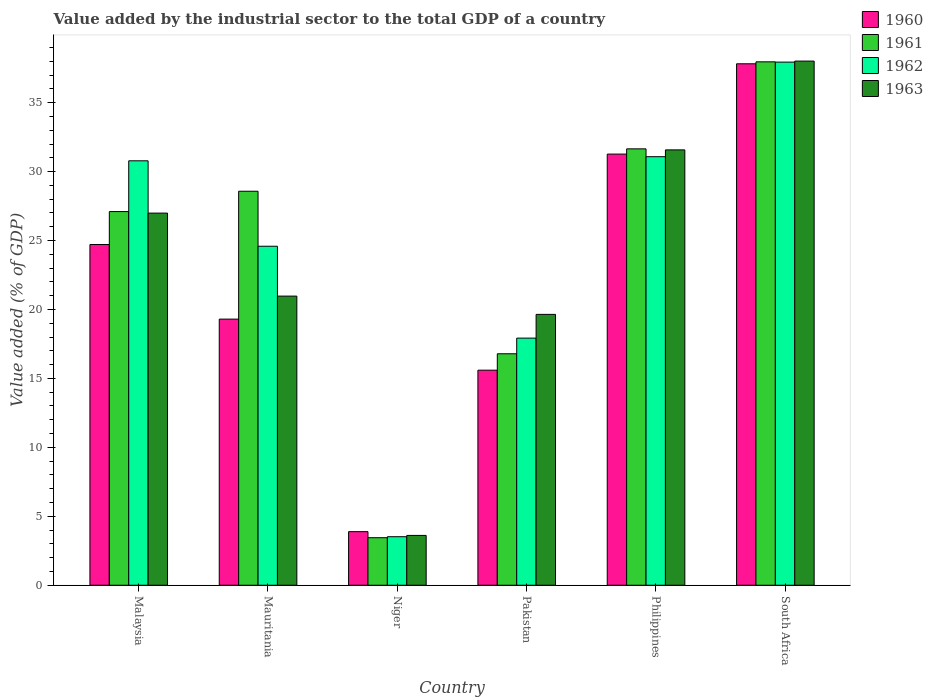Are the number of bars per tick equal to the number of legend labels?
Provide a succinct answer. Yes. How many bars are there on the 3rd tick from the left?
Give a very brief answer. 4. How many bars are there on the 6th tick from the right?
Your response must be concise. 4. What is the label of the 1st group of bars from the left?
Provide a short and direct response. Malaysia. What is the value added by the industrial sector to the total GDP in 1960 in Mauritania?
Offer a very short reply. 19.3. Across all countries, what is the maximum value added by the industrial sector to the total GDP in 1961?
Your response must be concise. 37.96. Across all countries, what is the minimum value added by the industrial sector to the total GDP in 1961?
Give a very brief answer. 3.45. In which country was the value added by the industrial sector to the total GDP in 1961 maximum?
Ensure brevity in your answer.  South Africa. In which country was the value added by the industrial sector to the total GDP in 1961 minimum?
Your answer should be very brief. Niger. What is the total value added by the industrial sector to the total GDP in 1963 in the graph?
Offer a terse response. 140.8. What is the difference between the value added by the industrial sector to the total GDP in 1963 in Mauritania and that in South Africa?
Provide a succinct answer. -17.04. What is the difference between the value added by the industrial sector to the total GDP in 1963 in Niger and the value added by the industrial sector to the total GDP in 1962 in Philippines?
Your answer should be compact. -27.47. What is the average value added by the industrial sector to the total GDP in 1962 per country?
Ensure brevity in your answer.  24.3. What is the difference between the value added by the industrial sector to the total GDP of/in 1961 and value added by the industrial sector to the total GDP of/in 1962 in Malaysia?
Give a very brief answer. -3.68. What is the ratio of the value added by the industrial sector to the total GDP in 1963 in Malaysia to that in Pakistan?
Provide a succinct answer. 1.37. What is the difference between the highest and the second highest value added by the industrial sector to the total GDP in 1962?
Offer a terse response. 7.16. What is the difference between the highest and the lowest value added by the industrial sector to the total GDP in 1961?
Offer a terse response. 34.51. In how many countries, is the value added by the industrial sector to the total GDP in 1960 greater than the average value added by the industrial sector to the total GDP in 1960 taken over all countries?
Offer a very short reply. 3. What does the 3rd bar from the right in Mauritania represents?
Give a very brief answer. 1961. Are all the bars in the graph horizontal?
Your response must be concise. No. Are the values on the major ticks of Y-axis written in scientific E-notation?
Keep it short and to the point. No. What is the title of the graph?
Your response must be concise. Value added by the industrial sector to the total GDP of a country. What is the label or title of the Y-axis?
Provide a succinct answer. Value added (% of GDP). What is the Value added (% of GDP) in 1960 in Malaysia?
Ensure brevity in your answer.  24.71. What is the Value added (% of GDP) of 1961 in Malaysia?
Ensure brevity in your answer.  27.1. What is the Value added (% of GDP) in 1962 in Malaysia?
Provide a short and direct response. 30.78. What is the Value added (% of GDP) of 1963 in Malaysia?
Give a very brief answer. 26.99. What is the Value added (% of GDP) in 1960 in Mauritania?
Provide a short and direct response. 19.3. What is the Value added (% of GDP) of 1961 in Mauritania?
Keep it short and to the point. 28.57. What is the Value added (% of GDP) of 1962 in Mauritania?
Your answer should be very brief. 24.59. What is the Value added (% of GDP) of 1963 in Mauritania?
Provide a short and direct response. 20.97. What is the Value added (% of GDP) in 1960 in Niger?
Your answer should be compact. 3.89. What is the Value added (% of GDP) of 1961 in Niger?
Provide a short and direct response. 3.45. What is the Value added (% of GDP) of 1962 in Niger?
Give a very brief answer. 3.52. What is the Value added (% of GDP) of 1963 in Niger?
Offer a very short reply. 3.61. What is the Value added (% of GDP) in 1960 in Pakistan?
Make the answer very short. 15.6. What is the Value added (% of GDP) in 1961 in Pakistan?
Give a very brief answer. 16.79. What is the Value added (% of GDP) in 1962 in Pakistan?
Provide a succinct answer. 17.92. What is the Value added (% of GDP) of 1963 in Pakistan?
Keep it short and to the point. 19.64. What is the Value added (% of GDP) of 1960 in Philippines?
Your answer should be compact. 31.27. What is the Value added (% of GDP) in 1961 in Philippines?
Your answer should be very brief. 31.65. What is the Value added (% of GDP) in 1962 in Philippines?
Give a very brief answer. 31.08. What is the Value added (% of GDP) of 1963 in Philippines?
Your answer should be compact. 31.57. What is the Value added (% of GDP) of 1960 in South Africa?
Provide a succinct answer. 37.82. What is the Value added (% of GDP) of 1961 in South Africa?
Keep it short and to the point. 37.96. What is the Value added (% of GDP) of 1962 in South Africa?
Provide a short and direct response. 37.94. What is the Value added (% of GDP) of 1963 in South Africa?
Give a very brief answer. 38.01. Across all countries, what is the maximum Value added (% of GDP) of 1960?
Offer a very short reply. 37.82. Across all countries, what is the maximum Value added (% of GDP) in 1961?
Your response must be concise. 37.96. Across all countries, what is the maximum Value added (% of GDP) of 1962?
Provide a short and direct response. 37.94. Across all countries, what is the maximum Value added (% of GDP) of 1963?
Your response must be concise. 38.01. Across all countries, what is the minimum Value added (% of GDP) of 1960?
Ensure brevity in your answer.  3.89. Across all countries, what is the minimum Value added (% of GDP) of 1961?
Give a very brief answer. 3.45. Across all countries, what is the minimum Value added (% of GDP) in 1962?
Provide a short and direct response. 3.52. Across all countries, what is the minimum Value added (% of GDP) in 1963?
Ensure brevity in your answer.  3.61. What is the total Value added (% of GDP) of 1960 in the graph?
Keep it short and to the point. 132.58. What is the total Value added (% of GDP) of 1961 in the graph?
Provide a short and direct response. 145.51. What is the total Value added (% of GDP) in 1962 in the graph?
Your response must be concise. 145.83. What is the total Value added (% of GDP) in 1963 in the graph?
Ensure brevity in your answer.  140.8. What is the difference between the Value added (% of GDP) of 1960 in Malaysia and that in Mauritania?
Give a very brief answer. 5.41. What is the difference between the Value added (% of GDP) of 1961 in Malaysia and that in Mauritania?
Keep it short and to the point. -1.47. What is the difference between the Value added (% of GDP) in 1962 in Malaysia and that in Mauritania?
Give a very brief answer. 6.2. What is the difference between the Value added (% of GDP) of 1963 in Malaysia and that in Mauritania?
Offer a terse response. 6.02. What is the difference between the Value added (% of GDP) in 1960 in Malaysia and that in Niger?
Provide a short and direct response. 20.83. What is the difference between the Value added (% of GDP) of 1961 in Malaysia and that in Niger?
Ensure brevity in your answer.  23.65. What is the difference between the Value added (% of GDP) in 1962 in Malaysia and that in Niger?
Offer a terse response. 27.26. What is the difference between the Value added (% of GDP) in 1963 in Malaysia and that in Niger?
Keep it short and to the point. 23.38. What is the difference between the Value added (% of GDP) in 1960 in Malaysia and that in Pakistan?
Provide a succinct answer. 9.11. What is the difference between the Value added (% of GDP) in 1961 in Malaysia and that in Pakistan?
Your answer should be very brief. 10.31. What is the difference between the Value added (% of GDP) of 1962 in Malaysia and that in Pakistan?
Offer a very short reply. 12.86. What is the difference between the Value added (% of GDP) in 1963 in Malaysia and that in Pakistan?
Offer a terse response. 7.35. What is the difference between the Value added (% of GDP) of 1960 in Malaysia and that in Philippines?
Provide a succinct answer. -6.56. What is the difference between the Value added (% of GDP) of 1961 in Malaysia and that in Philippines?
Make the answer very short. -4.55. What is the difference between the Value added (% of GDP) of 1962 in Malaysia and that in Philippines?
Keep it short and to the point. -0.3. What is the difference between the Value added (% of GDP) of 1963 in Malaysia and that in Philippines?
Your answer should be very brief. -4.58. What is the difference between the Value added (% of GDP) of 1960 in Malaysia and that in South Africa?
Ensure brevity in your answer.  -13.11. What is the difference between the Value added (% of GDP) of 1961 in Malaysia and that in South Africa?
Make the answer very short. -10.86. What is the difference between the Value added (% of GDP) in 1962 in Malaysia and that in South Africa?
Offer a terse response. -7.16. What is the difference between the Value added (% of GDP) of 1963 in Malaysia and that in South Africa?
Offer a very short reply. -11.02. What is the difference between the Value added (% of GDP) of 1960 in Mauritania and that in Niger?
Offer a terse response. 15.41. What is the difference between the Value added (% of GDP) of 1961 in Mauritania and that in Niger?
Your answer should be compact. 25.13. What is the difference between the Value added (% of GDP) in 1962 in Mauritania and that in Niger?
Provide a short and direct response. 21.07. What is the difference between the Value added (% of GDP) of 1963 in Mauritania and that in Niger?
Ensure brevity in your answer.  17.36. What is the difference between the Value added (% of GDP) of 1960 in Mauritania and that in Pakistan?
Give a very brief answer. 3.7. What is the difference between the Value added (% of GDP) of 1961 in Mauritania and that in Pakistan?
Offer a very short reply. 11.79. What is the difference between the Value added (% of GDP) in 1962 in Mauritania and that in Pakistan?
Make the answer very short. 6.66. What is the difference between the Value added (% of GDP) of 1963 in Mauritania and that in Pakistan?
Ensure brevity in your answer.  1.33. What is the difference between the Value added (% of GDP) of 1960 in Mauritania and that in Philippines?
Your response must be concise. -11.97. What is the difference between the Value added (% of GDP) of 1961 in Mauritania and that in Philippines?
Offer a very short reply. -3.07. What is the difference between the Value added (% of GDP) of 1962 in Mauritania and that in Philippines?
Keep it short and to the point. -6.49. What is the difference between the Value added (% of GDP) in 1963 in Mauritania and that in Philippines?
Provide a succinct answer. -10.6. What is the difference between the Value added (% of GDP) of 1960 in Mauritania and that in South Africa?
Provide a succinct answer. -18.52. What is the difference between the Value added (% of GDP) in 1961 in Mauritania and that in South Africa?
Your answer should be compact. -9.38. What is the difference between the Value added (% of GDP) of 1962 in Mauritania and that in South Africa?
Your answer should be compact. -13.35. What is the difference between the Value added (% of GDP) of 1963 in Mauritania and that in South Africa?
Provide a short and direct response. -17.04. What is the difference between the Value added (% of GDP) in 1960 in Niger and that in Pakistan?
Your answer should be very brief. -11.71. What is the difference between the Value added (% of GDP) in 1961 in Niger and that in Pakistan?
Offer a terse response. -13.34. What is the difference between the Value added (% of GDP) in 1962 in Niger and that in Pakistan?
Ensure brevity in your answer.  -14.4. What is the difference between the Value added (% of GDP) of 1963 in Niger and that in Pakistan?
Offer a terse response. -16.03. What is the difference between the Value added (% of GDP) in 1960 in Niger and that in Philippines?
Your answer should be compact. -27.38. What is the difference between the Value added (% of GDP) of 1961 in Niger and that in Philippines?
Make the answer very short. -28.2. What is the difference between the Value added (% of GDP) of 1962 in Niger and that in Philippines?
Offer a very short reply. -27.56. What is the difference between the Value added (% of GDP) of 1963 in Niger and that in Philippines?
Ensure brevity in your answer.  -27.96. What is the difference between the Value added (% of GDP) of 1960 in Niger and that in South Africa?
Make the answer very short. -33.93. What is the difference between the Value added (% of GDP) of 1961 in Niger and that in South Africa?
Ensure brevity in your answer.  -34.51. What is the difference between the Value added (% of GDP) in 1962 in Niger and that in South Africa?
Make the answer very short. -34.42. What is the difference between the Value added (% of GDP) in 1963 in Niger and that in South Africa?
Keep it short and to the point. -34.4. What is the difference between the Value added (% of GDP) of 1960 in Pakistan and that in Philippines?
Provide a short and direct response. -15.67. What is the difference between the Value added (% of GDP) in 1961 in Pakistan and that in Philippines?
Provide a short and direct response. -14.86. What is the difference between the Value added (% of GDP) in 1962 in Pakistan and that in Philippines?
Your answer should be compact. -13.16. What is the difference between the Value added (% of GDP) in 1963 in Pakistan and that in Philippines?
Your response must be concise. -11.93. What is the difference between the Value added (% of GDP) in 1960 in Pakistan and that in South Africa?
Your answer should be compact. -22.22. What is the difference between the Value added (% of GDP) in 1961 in Pakistan and that in South Africa?
Provide a short and direct response. -21.17. What is the difference between the Value added (% of GDP) in 1962 in Pakistan and that in South Africa?
Provide a short and direct response. -20.02. What is the difference between the Value added (% of GDP) of 1963 in Pakistan and that in South Africa?
Offer a very short reply. -18.37. What is the difference between the Value added (% of GDP) of 1960 in Philippines and that in South Africa?
Your response must be concise. -6.55. What is the difference between the Value added (% of GDP) in 1961 in Philippines and that in South Africa?
Keep it short and to the point. -6.31. What is the difference between the Value added (% of GDP) in 1962 in Philippines and that in South Africa?
Offer a very short reply. -6.86. What is the difference between the Value added (% of GDP) of 1963 in Philippines and that in South Africa?
Your answer should be compact. -6.44. What is the difference between the Value added (% of GDP) of 1960 in Malaysia and the Value added (% of GDP) of 1961 in Mauritania?
Make the answer very short. -3.86. What is the difference between the Value added (% of GDP) of 1960 in Malaysia and the Value added (% of GDP) of 1962 in Mauritania?
Offer a terse response. 0.13. What is the difference between the Value added (% of GDP) of 1960 in Malaysia and the Value added (% of GDP) of 1963 in Mauritania?
Provide a succinct answer. 3.74. What is the difference between the Value added (% of GDP) of 1961 in Malaysia and the Value added (% of GDP) of 1962 in Mauritania?
Provide a short and direct response. 2.51. What is the difference between the Value added (% of GDP) in 1961 in Malaysia and the Value added (% of GDP) in 1963 in Mauritania?
Make the answer very short. 6.13. What is the difference between the Value added (% of GDP) in 1962 in Malaysia and the Value added (% of GDP) in 1963 in Mauritania?
Keep it short and to the point. 9.81. What is the difference between the Value added (% of GDP) in 1960 in Malaysia and the Value added (% of GDP) in 1961 in Niger?
Provide a succinct answer. 21.27. What is the difference between the Value added (% of GDP) in 1960 in Malaysia and the Value added (% of GDP) in 1962 in Niger?
Make the answer very short. 21.19. What is the difference between the Value added (% of GDP) of 1960 in Malaysia and the Value added (% of GDP) of 1963 in Niger?
Offer a very short reply. 21.1. What is the difference between the Value added (% of GDP) of 1961 in Malaysia and the Value added (% of GDP) of 1962 in Niger?
Offer a terse response. 23.58. What is the difference between the Value added (% of GDP) of 1961 in Malaysia and the Value added (% of GDP) of 1963 in Niger?
Your answer should be very brief. 23.49. What is the difference between the Value added (% of GDP) of 1962 in Malaysia and the Value added (% of GDP) of 1963 in Niger?
Offer a terse response. 27.17. What is the difference between the Value added (% of GDP) of 1960 in Malaysia and the Value added (% of GDP) of 1961 in Pakistan?
Your answer should be compact. 7.92. What is the difference between the Value added (% of GDP) of 1960 in Malaysia and the Value added (% of GDP) of 1962 in Pakistan?
Your answer should be very brief. 6.79. What is the difference between the Value added (% of GDP) in 1960 in Malaysia and the Value added (% of GDP) in 1963 in Pakistan?
Provide a succinct answer. 5.07. What is the difference between the Value added (% of GDP) of 1961 in Malaysia and the Value added (% of GDP) of 1962 in Pakistan?
Make the answer very short. 9.18. What is the difference between the Value added (% of GDP) of 1961 in Malaysia and the Value added (% of GDP) of 1963 in Pakistan?
Offer a terse response. 7.46. What is the difference between the Value added (% of GDP) of 1962 in Malaysia and the Value added (% of GDP) of 1963 in Pakistan?
Your answer should be very brief. 11.14. What is the difference between the Value added (% of GDP) of 1960 in Malaysia and the Value added (% of GDP) of 1961 in Philippines?
Offer a terse response. -6.94. What is the difference between the Value added (% of GDP) in 1960 in Malaysia and the Value added (% of GDP) in 1962 in Philippines?
Provide a short and direct response. -6.37. What is the difference between the Value added (% of GDP) in 1960 in Malaysia and the Value added (% of GDP) in 1963 in Philippines?
Provide a succinct answer. -6.86. What is the difference between the Value added (% of GDP) in 1961 in Malaysia and the Value added (% of GDP) in 1962 in Philippines?
Keep it short and to the point. -3.98. What is the difference between the Value added (% of GDP) in 1961 in Malaysia and the Value added (% of GDP) in 1963 in Philippines?
Your answer should be compact. -4.47. What is the difference between the Value added (% of GDP) in 1962 in Malaysia and the Value added (% of GDP) in 1963 in Philippines?
Give a very brief answer. -0.79. What is the difference between the Value added (% of GDP) in 1960 in Malaysia and the Value added (% of GDP) in 1961 in South Africa?
Make the answer very short. -13.25. What is the difference between the Value added (% of GDP) of 1960 in Malaysia and the Value added (% of GDP) of 1962 in South Africa?
Offer a very short reply. -13.23. What is the difference between the Value added (% of GDP) in 1960 in Malaysia and the Value added (% of GDP) in 1963 in South Africa?
Provide a short and direct response. -13.3. What is the difference between the Value added (% of GDP) of 1961 in Malaysia and the Value added (% of GDP) of 1962 in South Africa?
Your response must be concise. -10.84. What is the difference between the Value added (% of GDP) of 1961 in Malaysia and the Value added (% of GDP) of 1963 in South Africa?
Keep it short and to the point. -10.91. What is the difference between the Value added (% of GDP) in 1962 in Malaysia and the Value added (% of GDP) in 1963 in South Africa?
Make the answer very short. -7.23. What is the difference between the Value added (% of GDP) of 1960 in Mauritania and the Value added (% of GDP) of 1961 in Niger?
Make the answer very short. 15.85. What is the difference between the Value added (% of GDP) of 1960 in Mauritania and the Value added (% of GDP) of 1962 in Niger?
Provide a succinct answer. 15.78. What is the difference between the Value added (% of GDP) of 1960 in Mauritania and the Value added (% of GDP) of 1963 in Niger?
Your response must be concise. 15.69. What is the difference between the Value added (% of GDP) of 1961 in Mauritania and the Value added (% of GDP) of 1962 in Niger?
Offer a terse response. 25.05. What is the difference between the Value added (% of GDP) in 1961 in Mauritania and the Value added (% of GDP) in 1963 in Niger?
Your response must be concise. 24.96. What is the difference between the Value added (% of GDP) of 1962 in Mauritania and the Value added (% of GDP) of 1963 in Niger?
Keep it short and to the point. 20.97. What is the difference between the Value added (% of GDP) in 1960 in Mauritania and the Value added (% of GDP) in 1961 in Pakistan?
Provide a succinct answer. 2.51. What is the difference between the Value added (% of GDP) in 1960 in Mauritania and the Value added (% of GDP) in 1962 in Pakistan?
Your answer should be compact. 1.38. What is the difference between the Value added (% of GDP) of 1960 in Mauritania and the Value added (% of GDP) of 1963 in Pakistan?
Keep it short and to the point. -0.34. What is the difference between the Value added (% of GDP) of 1961 in Mauritania and the Value added (% of GDP) of 1962 in Pakistan?
Keep it short and to the point. 10.65. What is the difference between the Value added (% of GDP) in 1961 in Mauritania and the Value added (% of GDP) in 1963 in Pakistan?
Offer a very short reply. 8.93. What is the difference between the Value added (% of GDP) of 1962 in Mauritania and the Value added (% of GDP) of 1963 in Pakistan?
Ensure brevity in your answer.  4.94. What is the difference between the Value added (% of GDP) of 1960 in Mauritania and the Value added (% of GDP) of 1961 in Philippines?
Your answer should be very brief. -12.35. What is the difference between the Value added (% of GDP) in 1960 in Mauritania and the Value added (% of GDP) in 1962 in Philippines?
Offer a very short reply. -11.78. What is the difference between the Value added (% of GDP) of 1960 in Mauritania and the Value added (% of GDP) of 1963 in Philippines?
Provide a short and direct response. -12.27. What is the difference between the Value added (% of GDP) of 1961 in Mauritania and the Value added (% of GDP) of 1962 in Philippines?
Keep it short and to the point. -2.51. What is the difference between the Value added (% of GDP) in 1961 in Mauritania and the Value added (% of GDP) in 1963 in Philippines?
Make the answer very short. -3. What is the difference between the Value added (% of GDP) in 1962 in Mauritania and the Value added (% of GDP) in 1963 in Philippines?
Provide a short and direct response. -6.99. What is the difference between the Value added (% of GDP) of 1960 in Mauritania and the Value added (% of GDP) of 1961 in South Africa?
Provide a short and direct response. -18.66. What is the difference between the Value added (% of GDP) in 1960 in Mauritania and the Value added (% of GDP) in 1962 in South Africa?
Offer a very short reply. -18.64. What is the difference between the Value added (% of GDP) in 1960 in Mauritania and the Value added (% of GDP) in 1963 in South Africa?
Your answer should be very brief. -18.71. What is the difference between the Value added (% of GDP) in 1961 in Mauritania and the Value added (% of GDP) in 1962 in South Africa?
Your response must be concise. -9.36. What is the difference between the Value added (% of GDP) in 1961 in Mauritania and the Value added (% of GDP) in 1963 in South Africa?
Your answer should be very brief. -9.44. What is the difference between the Value added (% of GDP) in 1962 in Mauritania and the Value added (% of GDP) in 1963 in South Africa?
Provide a short and direct response. -13.43. What is the difference between the Value added (% of GDP) of 1960 in Niger and the Value added (% of GDP) of 1961 in Pakistan?
Offer a very short reply. -12.9. What is the difference between the Value added (% of GDP) in 1960 in Niger and the Value added (% of GDP) in 1962 in Pakistan?
Offer a terse response. -14.04. What is the difference between the Value added (% of GDP) in 1960 in Niger and the Value added (% of GDP) in 1963 in Pakistan?
Your answer should be compact. -15.76. What is the difference between the Value added (% of GDP) in 1961 in Niger and the Value added (% of GDP) in 1962 in Pakistan?
Ensure brevity in your answer.  -14.48. What is the difference between the Value added (% of GDP) in 1961 in Niger and the Value added (% of GDP) in 1963 in Pakistan?
Keep it short and to the point. -16.2. What is the difference between the Value added (% of GDP) in 1962 in Niger and the Value added (% of GDP) in 1963 in Pakistan?
Ensure brevity in your answer.  -16.12. What is the difference between the Value added (% of GDP) in 1960 in Niger and the Value added (% of GDP) in 1961 in Philippines?
Provide a succinct answer. -27.76. What is the difference between the Value added (% of GDP) in 1960 in Niger and the Value added (% of GDP) in 1962 in Philippines?
Provide a succinct answer. -27.19. What is the difference between the Value added (% of GDP) of 1960 in Niger and the Value added (% of GDP) of 1963 in Philippines?
Your answer should be very brief. -27.69. What is the difference between the Value added (% of GDP) of 1961 in Niger and the Value added (% of GDP) of 1962 in Philippines?
Offer a very short reply. -27.63. What is the difference between the Value added (% of GDP) in 1961 in Niger and the Value added (% of GDP) in 1963 in Philippines?
Give a very brief answer. -28.13. What is the difference between the Value added (% of GDP) of 1962 in Niger and the Value added (% of GDP) of 1963 in Philippines?
Your answer should be very brief. -28.05. What is the difference between the Value added (% of GDP) in 1960 in Niger and the Value added (% of GDP) in 1961 in South Africa?
Make the answer very short. -34.07. What is the difference between the Value added (% of GDP) in 1960 in Niger and the Value added (% of GDP) in 1962 in South Africa?
Your answer should be very brief. -34.05. What is the difference between the Value added (% of GDP) in 1960 in Niger and the Value added (% of GDP) in 1963 in South Africa?
Give a very brief answer. -34.13. What is the difference between the Value added (% of GDP) in 1961 in Niger and the Value added (% of GDP) in 1962 in South Africa?
Provide a succinct answer. -34.49. What is the difference between the Value added (% of GDP) of 1961 in Niger and the Value added (% of GDP) of 1963 in South Africa?
Make the answer very short. -34.57. What is the difference between the Value added (% of GDP) of 1962 in Niger and the Value added (% of GDP) of 1963 in South Africa?
Ensure brevity in your answer.  -34.49. What is the difference between the Value added (% of GDP) of 1960 in Pakistan and the Value added (% of GDP) of 1961 in Philippines?
Offer a very short reply. -16.05. What is the difference between the Value added (% of GDP) of 1960 in Pakistan and the Value added (% of GDP) of 1962 in Philippines?
Your answer should be compact. -15.48. What is the difference between the Value added (% of GDP) of 1960 in Pakistan and the Value added (% of GDP) of 1963 in Philippines?
Provide a succinct answer. -15.98. What is the difference between the Value added (% of GDP) of 1961 in Pakistan and the Value added (% of GDP) of 1962 in Philippines?
Offer a very short reply. -14.29. What is the difference between the Value added (% of GDP) in 1961 in Pakistan and the Value added (% of GDP) in 1963 in Philippines?
Make the answer very short. -14.79. What is the difference between the Value added (% of GDP) in 1962 in Pakistan and the Value added (% of GDP) in 1963 in Philippines?
Your response must be concise. -13.65. What is the difference between the Value added (% of GDP) of 1960 in Pakistan and the Value added (% of GDP) of 1961 in South Africa?
Keep it short and to the point. -22.36. What is the difference between the Value added (% of GDP) in 1960 in Pakistan and the Value added (% of GDP) in 1962 in South Africa?
Offer a terse response. -22.34. What is the difference between the Value added (% of GDP) in 1960 in Pakistan and the Value added (% of GDP) in 1963 in South Africa?
Provide a short and direct response. -22.42. What is the difference between the Value added (% of GDP) of 1961 in Pakistan and the Value added (% of GDP) of 1962 in South Africa?
Your answer should be compact. -21.15. What is the difference between the Value added (% of GDP) of 1961 in Pakistan and the Value added (% of GDP) of 1963 in South Africa?
Your response must be concise. -21.23. What is the difference between the Value added (% of GDP) in 1962 in Pakistan and the Value added (% of GDP) in 1963 in South Africa?
Your answer should be very brief. -20.09. What is the difference between the Value added (% of GDP) in 1960 in Philippines and the Value added (% of GDP) in 1961 in South Africa?
Make the answer very short. -6.69. What is the difference between the Value added (% of GDP) in 1960 in Philippines and the Value added (% of GDP) in 1962 in South Africa?
Keep it short and to the point. -6.67. What is the difference between the Value added (% of GDP) in 1960 in Philippines and the Value added (% of GDP) in 1963 in South Africa?
Keep it short and to the point. -6.75. What is the difference between the Value added (% of GDP) in 1961 in Philippines and the Value added (% of GDP) in 1962 in South Africa?
Provide a succinct answer. -6.29. What is the difference between the Value added (% of GDP) in 1961 in Philippines and the Value added (% of GDP) in 1963 in South Africa?
Your answer should be very brief. -6.37. What is the difference between the Value added (% of GDP) in 1962 in Philippines and the Value added (% of GDP) in 1963 in South Africa?
Offer a terse response. -6.93. What is the average Value added (% of GDP) in 1960 per country?
Keep it short and to the point. 22.1. What is the average Value added (% of GDP) in 1961 per country?
Give a very brief answer. 24.25. What is the average Value added (% of GDP) of 1962 per country?
Keep it short and to the point. 24.3. What is the average Value added (% of GDP) of 1963 per country?
Provide a succinct answer. 23.47. What is the difference between the Value added (% of GDP) in 1960 and Value added (% of GDP) in 1961 in Malaysia?
Your response must be concise. -2.39. What is the difference between the Value added (% of GDP) in 1960 and Value added (% of GDP) in 1962 in Malaysia?
Your answer should be very brief. -6.07. What is the difference between the Value added (% of GDP) in 1960 and Value added (% of GDP) in 1963 in Malaysia?
Your answer should be very brief. -2.28. What is the difference between the Value added (% of GDP) in 1961 and Value added (% of GDP) in 1962 in Malaysia?
Offer a terse response. -3.68. What is the difference between the Value added (% of GDP) of 1961 and Value added (% of GDP) of 1963 in Malaysia?
Offer a terse response. 0.11. What is the difference between the Value added (% of GDP) in 1962 and Value added (% of GDP) in 1963 in Malaysia?
Ensure brevity in your answer.  3.79. What is the difference between the Value added (% of GDP) in 1960 and Value added (% of GDP) in 1961 in Mauritania?
Your answer should be compact. -9.27. What is the difference between the Value added (% of GDP) of 1960 and Value added (% of GDP) of 1962 in Mauritania?
Give a very brief answer. -5.29. What is the difference between the Value added (% of GDP) in 1960 and Value added (% of GDP) in 1963 in Mauritania?
Your answer should be very brief. -1.67. What is the difference between the Value added (% of GDP) in 1961 and Value added (% of GDP) in 1962 in Mauritania?
Provide a short and direct response. 3.99. What is the difference between the Value added (% of GDP) in 1961 and Value added (% of GDP) in 1963 in Mauritania?
Offer a terse response. 7.6. What is the difference between the Value added (% of GDP) of 1962 and Value added (% of GDP) of 1963 in Mauritania?
Ensure brevity in your answer.  3.62. What is the difference between the Value added (% of GDP) in 1960 and Value added (% of GDP) in 1961 in Niger?
Ensure brevity in your answer.  0.44. What is the difference between the Value added (% of GDP) in 1960 and Value added (% of GDP) in 1962 in Niger?
Keep it short and to the point. 0.37. What is the difference between the Value added (% of GDP) in 1960 and Value added (% of GDP) in 1963 in Niger?
Your response must be concise. 0.27. What is the difference between the Value added (% of GDP) in 1961 and Value added (% of GDP) in 1962 in Niger?
Provide a succinct answer. -0.07. What is the difference between the Value added (% of GDP) in 1961 and Value added (% of GDP) in 1963 in Niger?
Make the answer very short. -0.17. What is the difference between the Value added (% of GDP) of 1962 and Value added (% of GDP) of 1963 in Niger?
Offer a very short reply. -0.09. What is the difference between the Value added (% of GDP) in 1960 and Value added (% of GDP) in 1961 in Pakistan?
Ensure brevity in your answer.  -1.19. What is the difference between the Value added (% of GDP) in 1960 and Value added (% of GDP) in 1962 in Pakistan?
Your answer should be very brief. -2.33. What is the difference between the Value added (% of GDP) of 1960 and Value added (% of GDP) of 1963 in Pakistan?
Ensure brevity in your answer.  -4.05. What is the difference between the Value added (% of GDP) in 1961 and Value added (% of GDP) in 1962 in Pakistan?
Provide a succinct answer. -1.14. What is the difference between the Value added (% of GDP) of 1961 and Value added (% of GDP) of 1963 in Pakistan?
Provide a short and direct response. -2.86. What is the difference between the Value added (% of GDP) of 1962 and Value added (% of GDP) of 1963 in Pakistan?
Ensure brevity in your answer.  -1.72. What is the difference between the Value added (% of GDP) in 1960 and Value added (% of GDP) in 1961 in Philippines?
Keep it short and to the point. -0.38. What is the difference between the Value added (% of GDP) in 1960 and Value added (% of GDP) in 1962 in Philippines?
Your answer should be very brief. 0.19. What is the difference between the Value added (% of GDP) of 1960 and Value added (% of GDP) of 1963 in Philippines?
Your response must be concise. -0.3. What is the difference between the Value added (% of GDP) of 1961 and Value added (% of GDP) of 1962 in Philippines?
Offer a very short reply. 0.57. What is the difference between the Value added (% of GDP) in 1961 and Value added (% of GDP) in 1963 in Philippines?
Keep it short and to the point. 0.08. What is the difference between the Value added (% of GDP) of 1962 and Value added (% of GDP) of 1963 in Philippines?
Keep it short and to the point. -0.49. What is the difference between the Value added (% of GDP) in 1960 and Value added (% of GDP) in 1961 in South Africa?
Ensure brevity in your answer.  -0.14. What is the difference between the Value added (% of GDP) in 1960 and Value added (% of GDP) in 1962 in South Africa?
Your answer should be very brief. -0.12. What is the difference between the Value added (% of GDP) in 1960 and Value added (% of GDP) in 1963 in South Africa?
Offer a terse response. -0.2. What is the difference between the Value added (% of GDP) in 1961 and Value added (% of GDP) in 1962 in South Africa?
Ensure brevity in your answer.  0.02. What is the difference between the Value added (% of GDP) in 1961 and Value added (% of GDP) in 1963 in South Africa?
Offer a terse response. -0.05. What is the difference between the Value added (% of GDP) of 1962 and Value added (% of GDP) of 1963 in South Africa?
Provide a succinct answer. -0.08. What is the ratio of the Value added (% of GDP) of 1960 in Malaysia to that in Mauritania?
Offer a very short reply. 1.28. What is the ratio of the Value added (% of GDP) of 1961 in Malaysia to that in Mauritania?
Your response must be concise. 0.95. What is the ratio of the Value added (% of GDP) of 1962 in Malaysia to that in Mauritania?
Keep it short and to the point. 1.25. What is the ratio of the Value added (% of GDP) in 1963 in Malaysia to that in Mauritania?
Provide a succinct answer. 1.29. What is the ratio of the Value added (% of GDP) in 1960 in Malaysia to that in Niger?
Give a very brief answer. 6.36. What is the ratio of the Value added (% of GDP) of 1961 in Malaysia to that in Niger?
Give a very brief answer. 7.86. What is the ratio of the Value added (% of GDP) in 1962 in Malaysia to that in Niger?
Make the answer very short. 8.75. What is the ratio of the Value added (% of GDP) of 1963 in Malaysia to that in Niger?
Offer a terse response. 7.47. What is the ratio of the Value added (% of GDP) of 1960 in Malaysia to that in Pakistan?
Provide a succinct answer. 1.58. What is the ratio of the Value added (% of GDP) in 1961 in Malaysia to that in Pakistan?
Keep it short and to the point. 1.61. What is the ratio of the Value added (% of GDP) of 1962 in Malaysia to that in Pakistan?
Provide a short and direct response. 1.72. What is the ratio of the Value added (% of GDP) of 1963 in Malaysia to that in Pakistan?
Your answer should be compact. 1.37. What is the ratio of the Value added (% of GDP) in 1960 in Malaysia to that in Philippines?
Provide a short and direct response. 0.79. What is the ratio of the Value added (% of GDP) of 1961 in Malaysia to that in Philippines?
Your answer should be very brief. 0.86. What is the ratio of the Value added (% of GDP) of 1962 in Malaysia to that in Philippines?
Your answer should be compact. 0.99. What is the ratio of the Value added (% of GDP) of 1963 in Malaysia to that in Philippines?
Ensure brevity in your answer.  0.85. What is the ratio of the Value added (% of GDP) in 1960 in Malaysia to that in South Africa?
Provide a succinct answer. 0.65. What is the ratio of the Value added (% of GDP) in 1961 in Malaysia to that in South Africa?
Give a very brief answer. 0.71. What is the ratio of the Value added (% of GDP) of 1962 in Malaysia to that in South Africa?
Keep it short and to the point. 0.81. What is the ratio of the Value added (% of GDP) of 1963 in Malaysia to that in South Africa?
Your answer should be compact. 0.71. What is the ratio of the Value added (% of GDP) in 1960 in Mauritania to that in Niger?
Ensure brevity in your answer.  4.97. What is the ratio of the Value added (% of GDP) in 1961 in Mauritania to that in Niger?
Offer a very short reply. 8.29. What is the ratio of the Value added (% of GDP) in 1962 in Mauritania to that in Niger?
Keep it short and to the point. 6.99. What is the ratio of the Value added (% of GDP) in 1963 in Mauritania to that in Niger?
Offer a very short reply. 5.8. What is the ratio of the Value added (% of GDP) in 1960 in Mauritania to that in Pakistan?
Make the answer very short. 1.24. What is the ratio of the Value added (% of GDP) of 1961 in Mauritania to that in Pakistan?
Provide a succinct answer. 1.7. What is the ratio of the Value added (% of GDP) in 1962 in Mauritania to that in Pakistan?
Provide a short and direct response. 1.37. What is the ratio of the Value added (% of GDP) in 1963 in Mauritania to that in Pakistan?
Keep it short and to the point. 1.07. What is the ratio of the Value added (% of GDP) of 1960 in Mauritania to that in Philippines?
Ensure brevity in your answer.  0.62. What is the ratio of the Value added (% of GDP) of 1961 in Mauritania to that in Philippines?
Offer a terse response. 0.9. What is the ratio of the Value added (% of GDP) in 1962 in Mauritania to that in Philippines?
Your answer should be compact. 0.79. What is the ratio of the Value added (% of GDP) of 1963 in Mauritania to that in Philippines?
Ensure brevity in your answer.  0.66. What is the ratio of the Value added (% of GDP) in 1960 in Mauritania to that in South Africa?
Offer a terse response. 0.51. What is the ratio of the Value added (% of GDP) of 1961 in Mauritania to that in South Africa?
Give a very brief answer. 0.75. What is the ratio of the Value added (% of GDP) of 1962 in Mauritania to that in South Africa?
Keep it short and to the point. 0.65. What is the ratio of the Value added (% of GDP) of 1963 in Mauritania to that in South Africa?
Keep it short and to the point. 0.55. What is the ratio of the Value added (% of GDP) in 1960 in Niger to that in Pakistan?
Make the answer very short. 0.25. What is the ratio of the Value added (% of GDP) of 1961 in Niger to that in Pakistan?
Provide a short and direct response. 0.21. What is the ratio of the Value added (% of GDP) of 1962 in Niger to that in Pakistan?
Your answer should be compact. 0.2. What is the ratio of the Value added (% of GDP) of 1963 in Niger to that in Pakistan?
Your answer should be very brief. 0.18. What is the ratio of the Value added (% of GDP) in 1960 in Niger to that in Philippines?
Give a very brief answer. 0.12. What is the ratio of the Value added (% of GDP) in 1961 in Niger to that in Philippines?
Ensure brevity in your answer.  0.11. What is the ratio of the Value added (% of GDP) in 1962 in Niger to that in Philippines?
Offer a very short reply. 0.11. What is the ratio of the Value added (% of GDP) in 1963 in Niger to that in Philippines?
Provide a short and direct response. 0.11. What is the ratio of the Value added (% of GDP) of 1960 in Niger to that in South Africa?
Provide a short and direct response. 0.1. What is the ratio of the Value added (% of GDP) of 1961 in Niger to that in South Africa?
Provide a succinct answer. 0.09. What is the ratio of the Value added (% of GDP) in 1962 in Niger to that in South Africa?
Make the answer very short. 0.09. What is the ratio of the Value added (% of GDP) in 1963 in Niger to that in South Africa?
Provide a succinct answer. 0.1. What is the ratio of the Value added (% of GDP) in 1960 in Pakistan to that in Philippines?
Your answer should be compact. 0.5. What is the ratio of the Value added (% of GDP) of 1961 in Pakistan to that in Philippines?
Make the answer very short. 0.53. What is the ratio of the Value added (% of GDP) of 1962 in Pakistan to that in Philippines?
Offer a very short reply. 0.58. What is the ratio of the Value added (% of GDP) of 1963 in Pakistan to that in Philippines?
Provide a succinct answer. 0.62. What is the ratio of the Value added (% of GDP) in 1960 in Pakistan to that in South Africa?
Offer a very short reply. 0.41. What is the ratio of the Value added (% of GDP) of 1961 in Pakistan to that in South Africa?
Offer a very short reply. 0.44. What is the ratio of the Value added (% of GDP) in 1962 in Pakistan to that in South Africa?
Your answer should be compact. 0.47. What is the ratio of the Value added (% of GDP) of 1963 in Pakistan to that in South Africa?
Your response must be concise. 0.52. What is the ratio of the Value added (% of GDP) of 1960 in Philippines to that in South Africa?
Offer a very short reply. 0.83. What is the ratio of the Value added (% of GDP) in 1961 in Philippines to that in South Africa?
Make the answer very short. 0.83. What is the ratio of the Value added (% of GDP) in 1962 in Philippines to that in South Africa?
Provide a short and direct response. 0.82. What is the ratio of the Value added (% of GDP) of 1963 in Philippines to that in South Africa?
Keep it short and to the point. 0.83. What is the difference between the highest and the second highest Value added (% of GDP) in 1960?
Your answer should be very brief. 6.55. What is the difference between the highest and the second highest Value added (% of GDP) in 1961?
Keep it short and to the point. 6.31. What is the difference between the highest and the second highest Value added (% of GDP) in 1962?
Provide a succinct answer. 6.86. What is the difference between the highest and the second highest Value added (% of GDP) of 1963?
Ensure brevity in your answer.  6.44. What is the difference between the highest and the lowest Value added (% of GDP) of 1960?
Provide a short and direct response. 33.93. What is the difference between the highest and the lowest Value added (% of GDP) in 1961?
Give a very brief answer. 34.51. What is the difference between the highest and the lowest Value added (% of GDP) in 1962?
Offer a very short reply. 34.42. What is the difference between the highest and the lowest Value added (% of GDP) of 1963?
Your response must be concise. 34.4. 